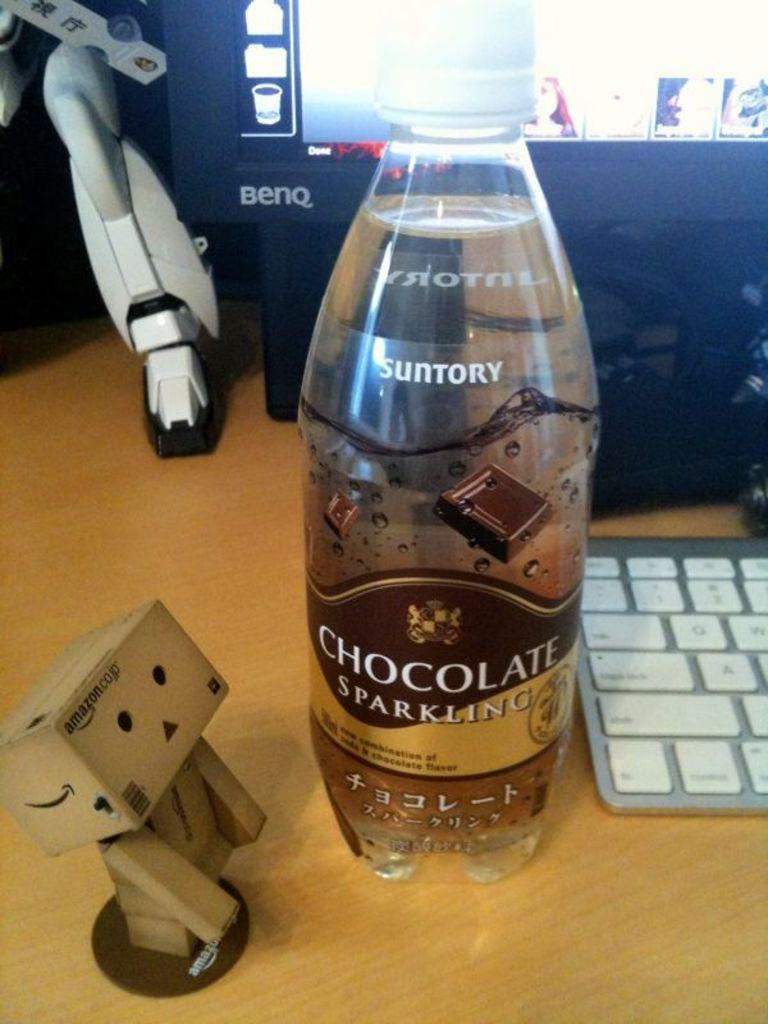<image>
Render a clear and concise summary of the photo. A bottle of chocolate sparkling beverage is made by Suntory. 